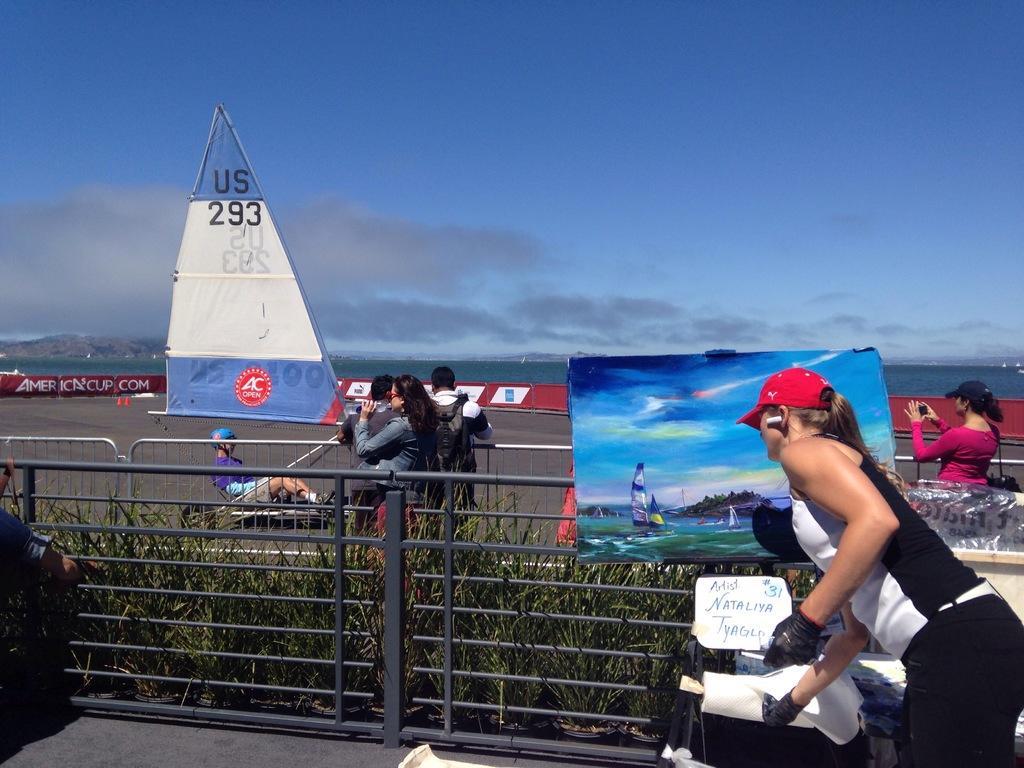In one or two sentences, can you explain what this image depicts? In the image there is a woman in the foreground and in front of the women there are some items and there is an iron fencing, in between the fencing there are plants and there is some painting attached to the rods of the fencing. Behind that there is a road and there are few people standing on the road, in the background there is a water surface. 